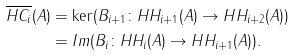<formula> <loc_0><loc_0><loc_500><loc_500>\overline { H C _ { i } } ( A ) & = \ker ( B _ { i + 1 } \colon H H _ { i + 1 } ( A ) \rightarrow H H _ { i + 2 } ( A ) ) \\ & = I m ( B _ { i } \colon H H _ { i } ( A ) \rightarrow H H _ { i + 1 } ( A ) ) .</formula> 